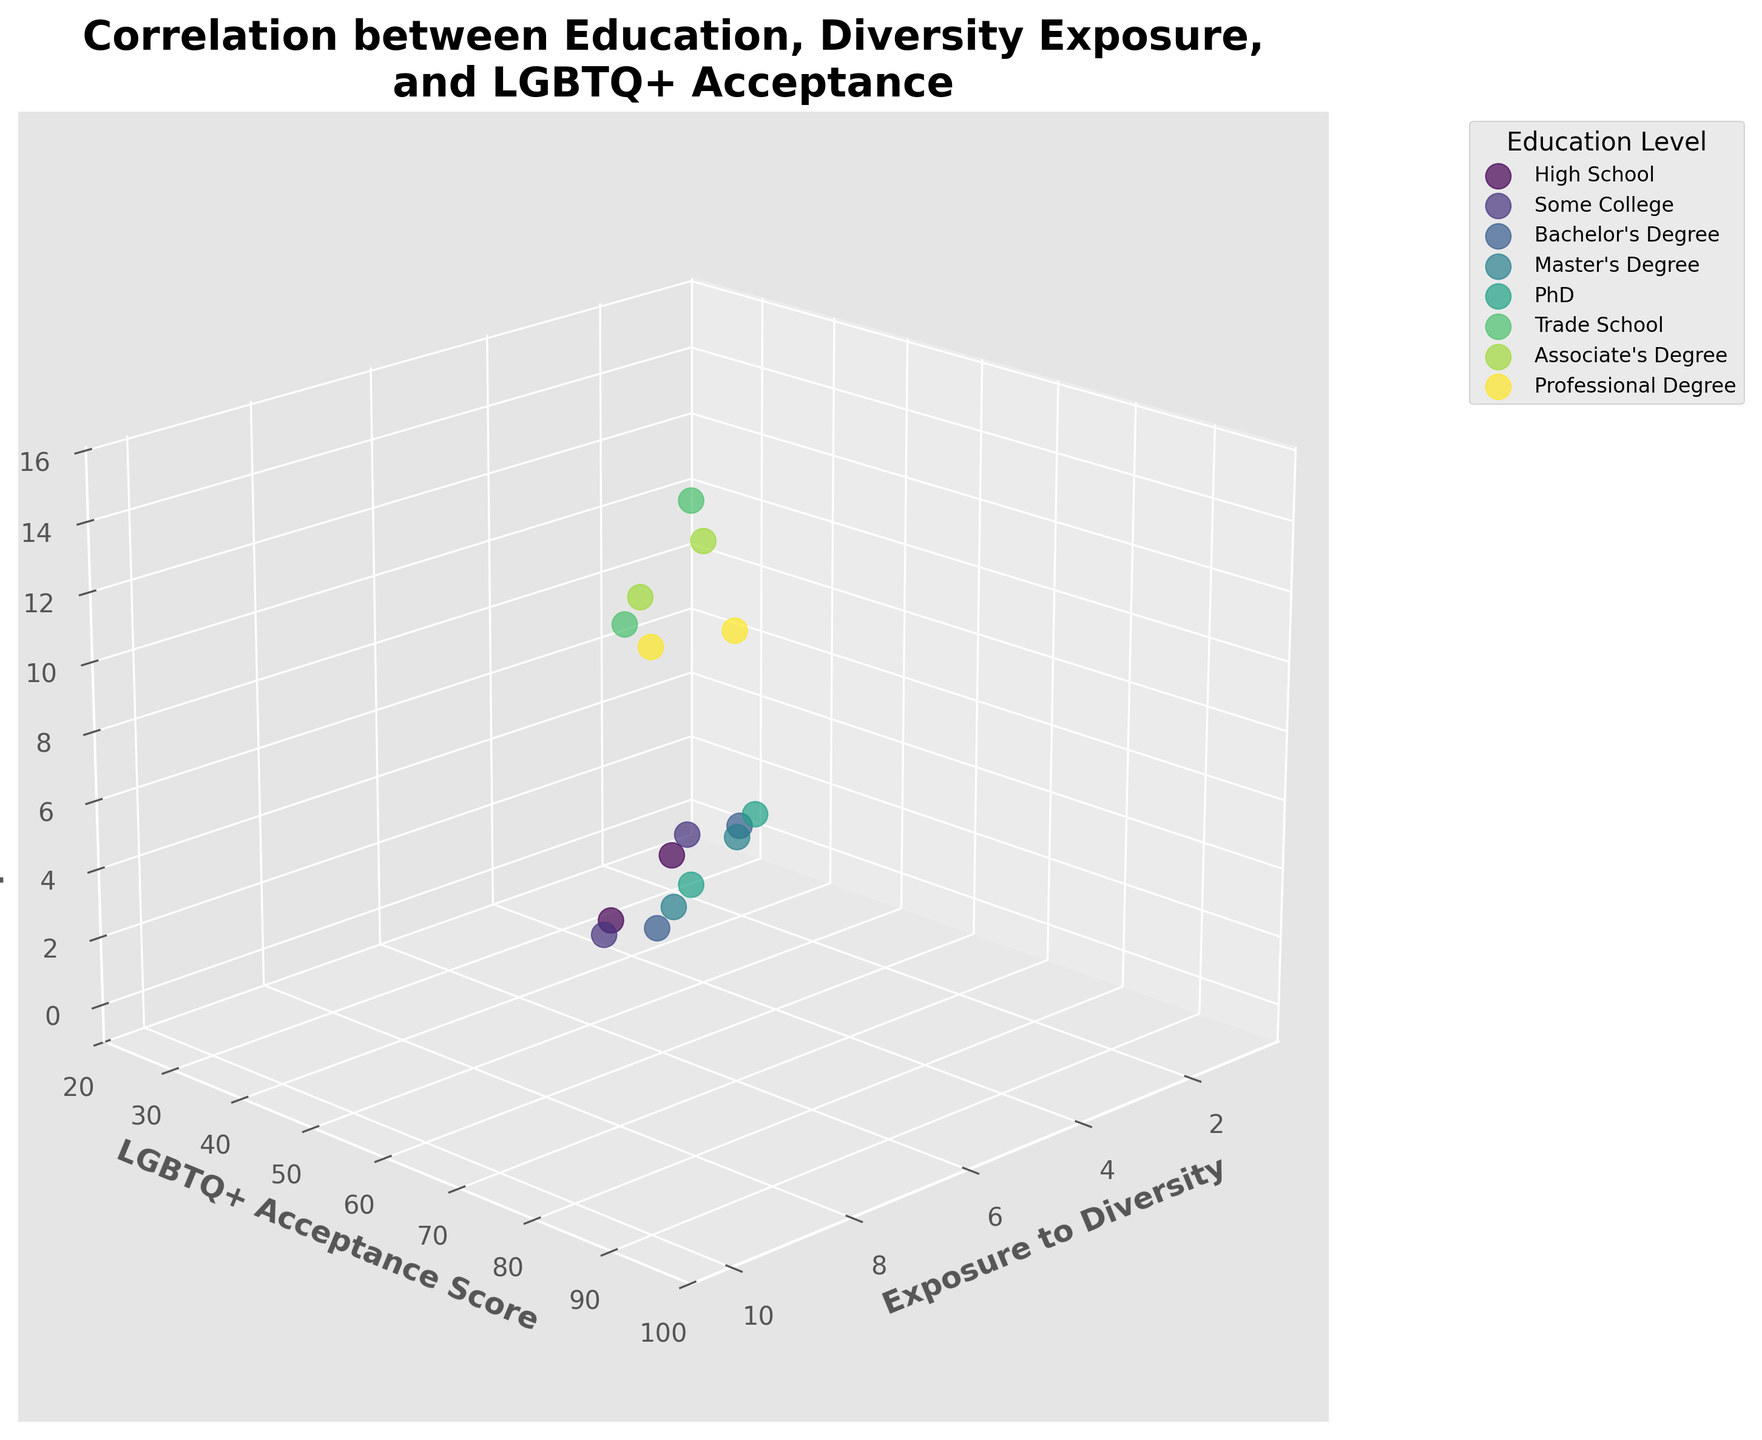What is the title of the figure? The title is located at the top of the figure and summarizes the main idea being represented by the visual data. The figure's title is "Correlation between Education, Diversity Exposure, and LGBTQ+ Acceptance."
Answer: Correlation between Education, Diversity Exposure, and LGBTQ+ Acceptance Which axis represents "Exposure to Diversity"? By observing the labels on each axis, you can see that the x-axis is labeled as "Exposure to Diversity."
Answer: x-axis What color is used to represent data points from people with "PhD"? The plot uses different colors for each education level. Data points for "PhD" are represented by the color assigned to them, which is distinguishable from other education levels.
Answer: Dark green How many unique education levels are represented in the figure? Counting the number of unique labels in the legend (each representing a different education level), we can see that there are seven unique education levels.
Answer: Seven What is the range of the "LGBTQ+ Acceptance Score" for individuals with a "Bachelor's Degree"? Looking at the data points representing "Bachelor's Degree," the lowest score is 55, and the highest score is 75.
Answer: 55 to 75 Which education level has the highest "LGBTQ+ Acceptance Score" and what is that score? By examining the highest point on the “LGBTQ+ Acceptance Score” axis and noting the education level associated with it, the highest score is for a "PhD," which is 95.
Answer: PhD, 95 Compare the "Exposure to Diversity" for individuals with a "High School" education level and a "Master's Degree." Which group has the higher average exposure? To find the average exposure, sum the "Exposure to Diversity" values for each group and then divide by the number of data points. For "High School": (2 + 5)/2 = 3.5. For "Master's Degree": (6 + 9)/2 = 7.5.
Answer: Master's Degree What is the average "LGBTQ+ Acceptance Score" for individuals with an "Associate's Degree"? Sum the "LGBTQ+ Acceptance Scores" for those with an "Associate's Degree" (50 + 65) and divide by the number of data points (2): (50+65)/2 = 57.5.
Answer: 57.5 How does "Exposure to Diversity" tend to impact "LGBTQ+ Acceptance Score" based on the visual trend? Observing the trend of data points, generally, as "Exposure to Diversity" increases, "LGBTQ+ Acceptance Score" also increases across various education levels.
Answer: Positively correlated Which combination of education level and exposure to diversity shows a significant jump in LGBTQ+ acceptance score? Observing notable jumps in the data points, "Some College" moving from exposure score 3 to 7 demonstrates a significant increase in LGBTQ+ acceptance score from 40 to 60.
Answer: Some College, exposure from 3 to 7 